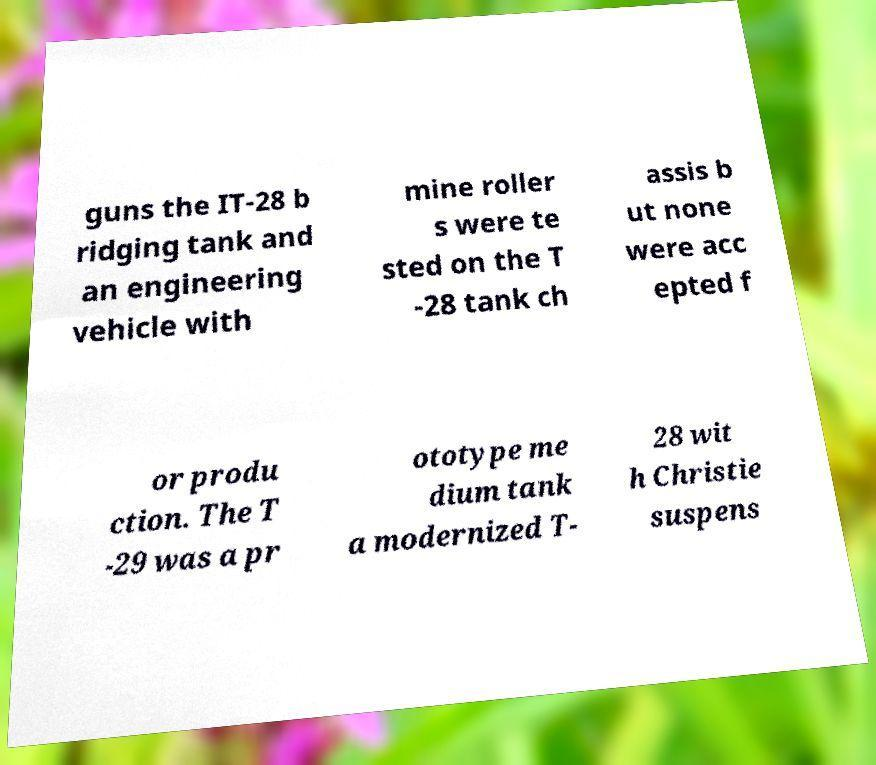Can you read and provide the text displayed in the image?This photo seems to have some interesting text. Can you extract and type it out for me? guns the IT-28 b ridging tank and an engineering vehicle with mine roller s were te sted on the T -28 tank ch assis b ut none were acc epted f or produ ction. The T -29 was a pr ototype me dium tank a modernized T- 28 wit h Christie suspens 